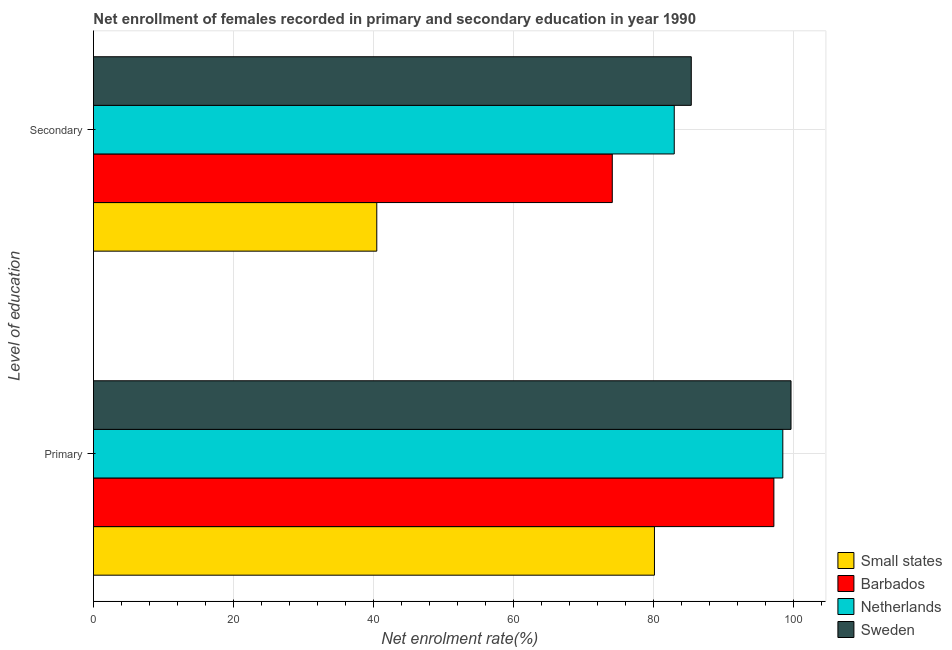How many different coloured bars are there?
Offer a terse response. 4. Are the number of bars per tick equal to the number of legend labels?
Ensure brevity in your answer.  Yes. How many bars are there on the 2nd tick from the bottom?
Offer a terse response. 4. What is the label of the 2nd group of bars from the top?
Offer a very short reply. Primary. What is the enrollment rate in primary education in Sweden?
Provide a short and direct response. 99.58. Across all countries, what is the maximum enrollment rate in secondary education?
Keep it short and to the point. 85.34. Across all countries, what is the minimum enrollment rate in primary education?
Provide a short and direct response. 80.08. In which country was the enrollment rate in primary education minimum?
Offer a very short reply. Small states. What is the total enrollment rate in secondary education in the graph?
Your response must be concise. 282.76. What is the difference between the enrollment rate in secondary education in Netherlands and that in Small states?
Your response must be concise. 42.46. What is the difference between the enrollment rate in secondary education in Barbados and the enrollment rate in primary education in Small states?
Provide a succinct answer. -6.02. What is the average enrollment rate in secondary education per country?
Provide a succinct answer. 70.69. What is the difference between the enrollment rate in secondary education and enrollment rate in primary education in Sweden?
Offer a terse response. -14.24. In how many countries, is the enrollment rate in primary education greater than 72 %?
Your response must be concise. 4. What is the ratio of the enrollment rate in secondary education in Small states to that in Sweden?
Keep it short and to the point. 0.47. Is the enrollment rate in secondary education in Netherlands less than that in Small states?
Keep it short and to the point. No. In how many countries, is the enrollment rate in primary education greater than the average enrollment rate in primary education taken over all countries?
Keep it short and to the point. 3. What does the 4th bar from the top in Primary represents?
Provide a short and direct response. Small states. What does the 1st bar from the bottom in Primary represents?
Provide a succinct answer. Small states. How many bars are there?
Offer a terse response. 8. Are all the bars in the graph horizontal?
Make the answer very short. Yes. Does the graph contain any zero values?
Provide a short and direct response. No. Where does the legend appear in the graph?
Your answer should be very brief. Bottom right. How are the legend labels stacked?
Offer a very short reply. Vertical. What is the title of the graph?
Provide a short and direct response. Net enrollment of females recorded in primary and secondary education in year 1990. Does "Latin America(all income levels)" appear as one of the legend labels in the graph?
Ensure brevity in your answer.  No. What is the label or title of the X-axis?
Keep it short and to the point. Net enrolment rate(%). What is the label or title of the Y-axis?
Make the answer very short. Level of education. What is the Net enrolment rate(%) in Small states in Primary?
Your answer should be very brief. 80.08. What is the Net enrolment rate(%) in Barbados in Primary?
Provide a short and direct response. 97.13. What is the Net enrolment rate(%) in Netherlands in Primary?
Give a very brief answer. 98.41. What is the Net enrolment rate(%) in Sweden in Primary?
Provide a short and direct response. 99.58. What is the Net enrolment rate(%) in Small states in Secondary?
Provide a succinct answer. 40.44. What is the Net enrolment rate(%) in Barbados in Secondary?
Give a very brief answer. 74.06. What is the Net enrolment rate(%) in Netherlands in Secondary?
Give a very brief answer. 82.91. What is the Net enrolment rate(%) of Sweden in Secondary?
Your answer should be very brief. 85.34. Across all Level of education, what is the maximum Net enrolment rate(%) in Small states?
Provide a short and direct response. 80.08. Across all Level of education, what is the maximum Net enrolment rate(%) in Barbados?
Offer a terse response. 97.13. Across all Level of education, what is the maximum Net enrolment rate(%) of Netherlands?
Your answer should be compact. 98.41. Across all Level of education, what is the maximum Net enrolment rate(%) of Sweden?
Offer a very short reply. 99.58. Across all Level of education, what is the minimum Net enrolment rate(%) of Small states?
Offer a very short reply. 40.44. Across all Level of education, what is the minimum Net enrolment rate(%) of Barbados?
Give a very brief answer. 74.06. Across all Level of education, what is the minimum Net enrolment rate(%) of Netherlands?
Provide a short and direct response. 82.91. Across all Level of education, what is the minimum Net enrolment rate(%) of Sweden?
Ensure brevity in your answer.  85.34. What is the total Net enrolment rate(%) in Small states in the graph?
Your response must be concise. 120.53. What is the total Net enrolment rate(%) of Barbados in the graph?
Your response must be concise. 171.2. What is the total Net enrolment rate(%) of Netherlands in the graph?
Give a very brief answer. 181.32. What is the total Net enrolment rate(%) in Sweden in the graph?
Your answer should be very brief. 184.92. What is the difference between the Net enrolment rate(%) in Small states in Primary and that in Secondary?
Ensure brevity in your answer.  39.64. What is the difference between the Net enrolment rate(%) of Barbados in Primary and that in Secondary?
Your answer should be very brief. 23.07. What is the difference between the Net enrolment rate(%) in Netherlands in Primary and that in Secondary?
Make the answer very short. 15.5. What is the difference between the Net enrolment rate(%) of Sweden in Primary and that in Secondary?
Your answer should be very brief. 14.24. What is the difference between the Net enrolment rate(%) in Small states in Primary and the Net enrolment rate(%) in Barbados in Secondary?
Provide a short and direct response. 6.02. What is the difference between the Net enrolment rate(%) of Small states in Primary and the Net enrolment rate(%) of Netherlands in Secondary?
Ensure brevity in your answer.  -2.83. What is the difference between the Net enrolment rate(%) in Small states in Primary and the Net enrolment rate(%) in Sweden in Secondary?
Your answer should be compact. -5.26. What is the difference between the Net enrolment rate(%) of Barbados in Primary and the Net enrolment rate(%) of Netherlands in Secondary?
Provide a short and direct response. 14.22. What is the difference between the Net enrolment rate(%) of Barbados in Primary and the Net enrolment rate(%) of Sweden in Secondary?
Your answer should be very brief. 11.79. What is the difference between the Net enrolment rate(%) of Netherlands in Primary and the Net enrolment rate(%) of Sweden in Secondary?
Make the answer very short. 13.07. What is the average Net enrolment rate(%) in Small states per Level of education?
Provide a succinct answer. 60.26. What is the average Net enrolment rate(%) in Barbados per Level of education?
Make the answer very short. 85.6. What is the average Net enrolment rate(%) of Netherlands per Level of education?
Ensure brevity in your answer.  90.66. What is the average Net enrolment rate(%) in Sweden per Level of education?
Ensure brevity in your answer.  92.46. What is the difference between the Net enrolment rate(%) in Small states and Net enrolment rate(%) in Barbados in Primary?
Offer a very short reply. -17.05. What is the difference between the Net enrolment rate(%) of Small states and Net enrolment rate(%) of Netherlands in Primary?
Offer a terse response. -18.32. What is the difference between the Net enrolment rate(%) of Small states and Net enrolment rate(%) of Sweden in Primary?
Ensure brevity in your answer.  -19.5. What is the difference between the Net enrolment rate(%) of Barbados and Net enrolment rate(%) of Netherlands in Primary?
Ensure brevity in your answer.  -1.28. What is the difference between the Net enrolment rate(%) of Barbados and Net enrolment rate(%) of Sweden in Primary?
Give a very brief answer. -2.45. What is the difference between the Net enrolment rate(%) of Netherlands and Net enrolment rate(%) of Sweden in Primary?
Provide a short and direct response. -1.17. What is the difference between the Net enrolment rate(%) in Small states and Net enrolment rate(%) in Barbados in Secondary?
Offer a very short reply. -33.62. What is the difference between the Net enrolment rate(%) of Small states and Net enrolment rate(%) of Netherlands in Secondary?
Provide a short and direct response. -42.46. What is the difference between the Net enrolment rate(%) in Small states and Net enrolment rate(%) in Sweden in Secondary?
Offer a terse response. -44.9. What is the difference between the Net enrolment rate(%) of Barbados and Net enrolment rate(%) of Netherlands in Secondary?
Ensure brevity in your answer.  -8.84. What is the difference between the Net enrolment rate(%) of Barbados and Net enrolment rate(%) of Sweden in Secondary?
Your response must be concise. -11.28. What is the difference between the Net enrolment rate(%) of Netherlands and Net enrolment rate(%) of Sweden in Secondary?
Keep it short and to the point. -2.43. What is the ratio of the Net enrolment rate(%) in Small states in Primary to that in Secondary?
Your answer should be very brief. 1.98. What is the ratio of the Net enrolment rate(%) of Barbados in Primary to that in Secondary?
Your response must be concise. 1.31. What is the ratio of the Net enrolment rate(%) in Netherlands in Primary to that in Secondary?
Your answer should be very brief. 1.19. What is the ratio of the Net enrolment rate(%) of Sweden in Primary to that in Secondary?
Your response must be concise. 1.17. What is the difference between the highest and the second highest Net enrolment rate(%) in Small states?
Provide a short and direct response. 39.64. What is the difference between the highest and the second highest Net enrolment rate(%) of Barbados?
Provide a succinct answer. 23.07. What is the difference between the highest and the second highest Net enrolment rate(%) in Netherlands?
Ensure brevity in your answer.  15.5. What is the difference between the highest and the second highest Net enrolment rate(%) in Sweden?
Give a very brief answer. 14.24. What is the difference between the highest and the lowest Net enrolment rate(%) in Small states?
Provide a short and direct response. 39.64. What is the difference between the highest and the lowest Net enrolment rate(%) of Barbados?
Ensure brevity in your answer.  23.07. What is the difference between the highest and the lowest Net enrolment rate(%) of Netherlands?
Offer a very short reply. 15.5. What is the difference between the highest and the lowest Net enrolment rate(%) in Sweden?
Give a very brief answer. 14.24. 